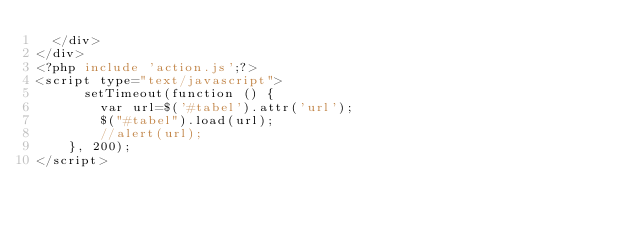<code> <loc_0><loc_0><loc_500><loc_500><_PHP_>	</div>
</div>
<?php include 'action.js';?>
<script type="text/javascript">
	    setTimeout(function () {
        var url=$('#tabel').attr('url');
        $("#tabel").load(url);
        //alert(url);
    }, 200); 
</script>
</code> 